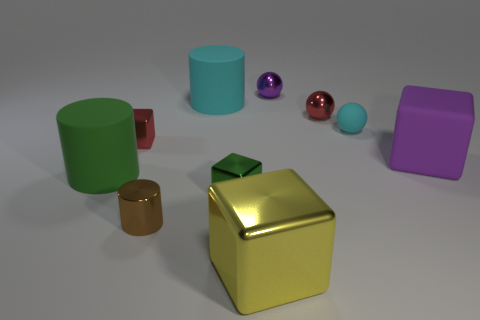Subtract all balls. How many objects are left? 7 Add 5 cyan matte cylinders. How many cyan matte cylinders exist? 6 Subtract 0 blue balls. How many objects are left? 10 Subtract all large rubber things. Subtract all tiny brown cylinders. How many objects are left? 6 Add 5 large shiny blocks. How many large shiny blocks are left? 6 